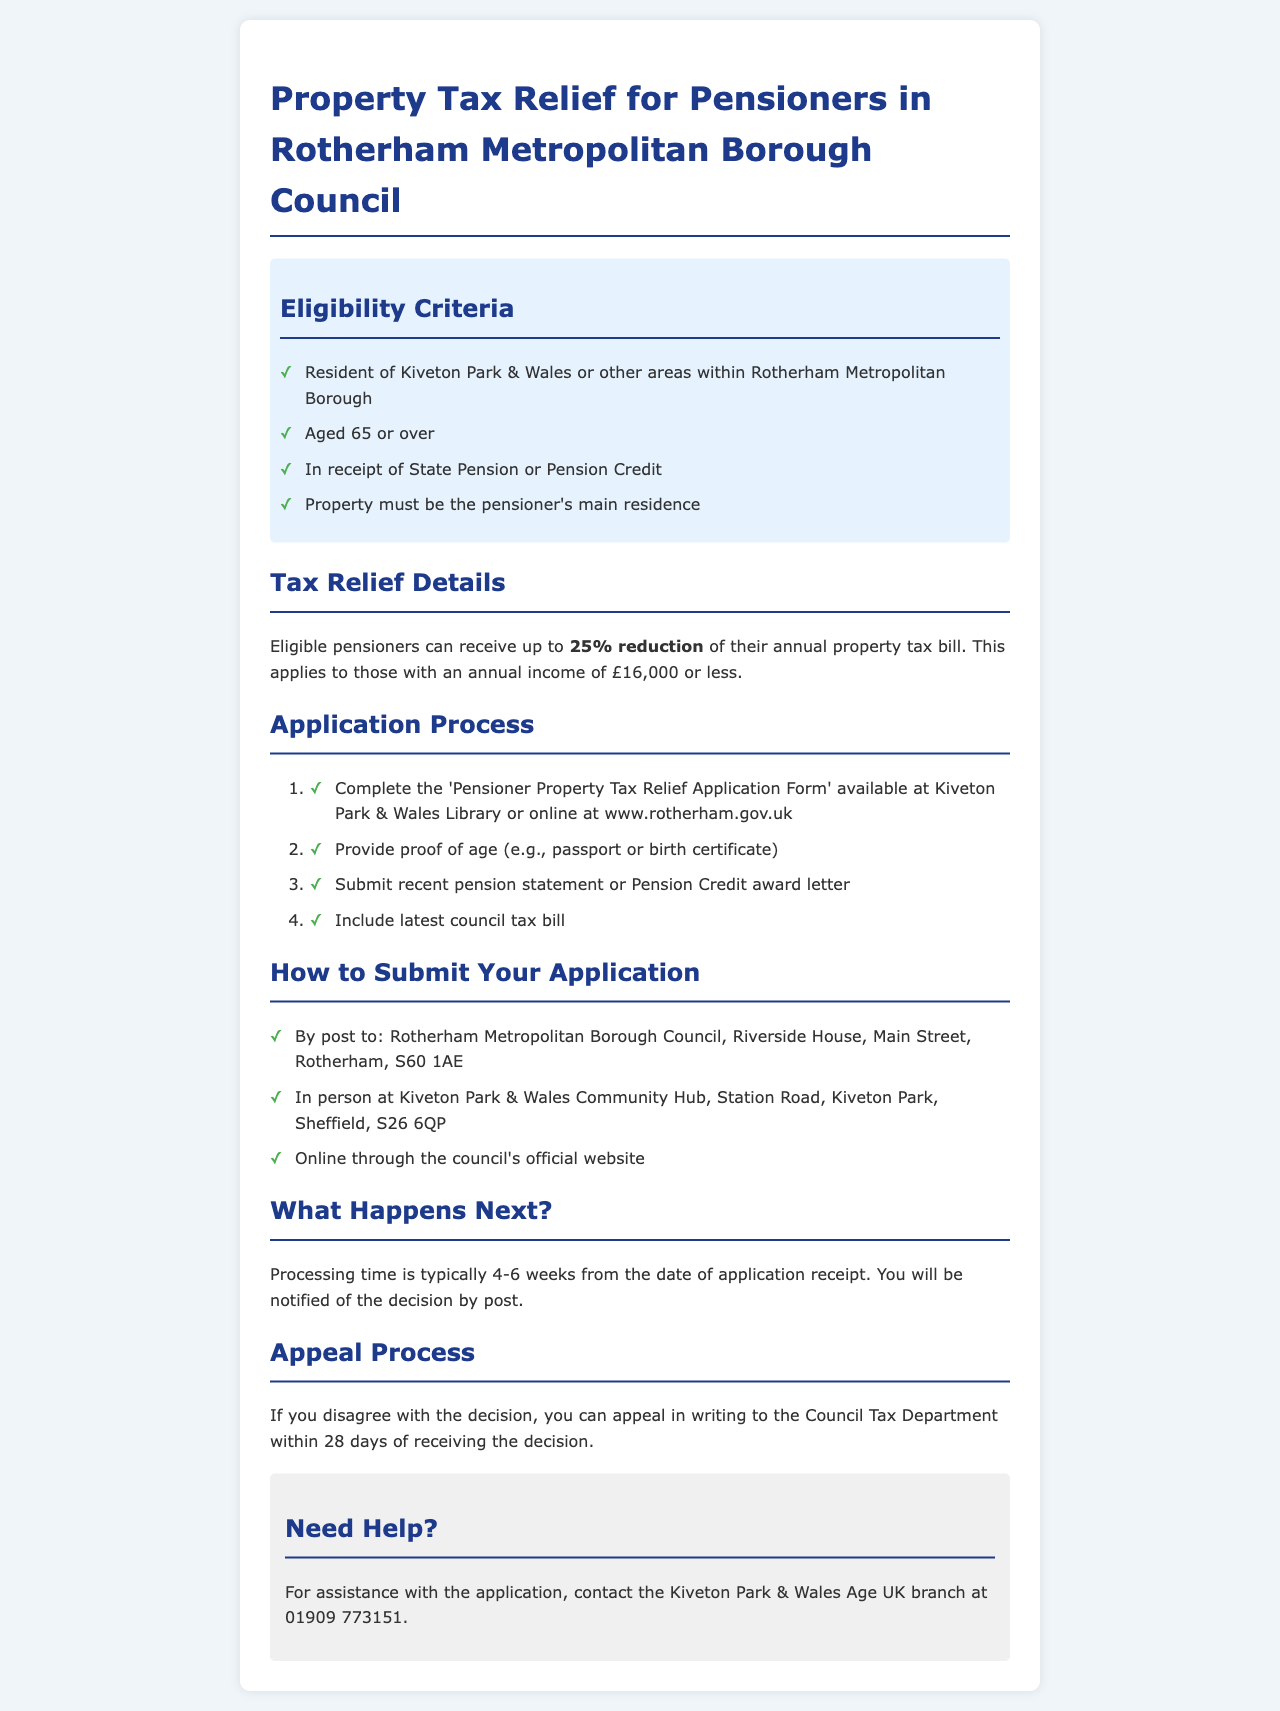What is the age requirement for pensioners? The document states that the age requirement for pensioners is 65 or over.
Answer: 65 or over How much reduction can eligible pensioners receive on their property tax bill? According to the document, eligible pensioners can receive up to a 25% reduction of their annual property tax bill.
Answer: 25% What is the income limit for eligibility? The income limit for eligibility is mentioned as £16,000 or less.
Answer: £16,000 or less Where can the application form be obtained? The document mentions the application form can be obtained at Kiveton Park & Wales Library or online.
Answer: Kiveton Park & Wales Library or online How long does processing typically take? The processing time is stated in the document as typically taking 4-6 weeks.
Answer: 4-6 weeks What proof of age is required for the application? The document states that proof of age can be provided by passport or birth certificate.
Answer: Passport or birth certificate What should be included with the application? The document lists the requirement to include a recent pension statement or Pension Credit award letter along with other documents.
Answer: Recent pension statement or Pension Credit award letter What happens if someone disagrees with the decision? If someone disagrees with the decision, they can appeal in writing to the Council Tax Department.
Answer: Appeal in writing to the Council Tax Department Who can assist with the application process? The document provides a contact for assistance with the application, specifically mentioning the Kiveton Park & Wales Age UK branch.
Answer: Kiveton Park & Wales Age UK branch 